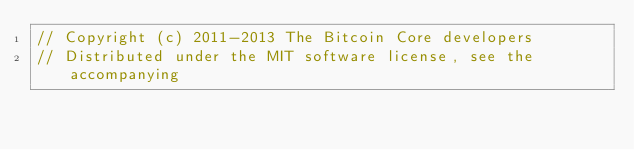Convert code to text. <code><loc_0><loc_0><loc_500><loc_500><_ObjectiveC_>// Copyright (c) 2011-2013 The Bitcoin Core developers
// Distributed under the MIT software license, see the accompanying</code> 